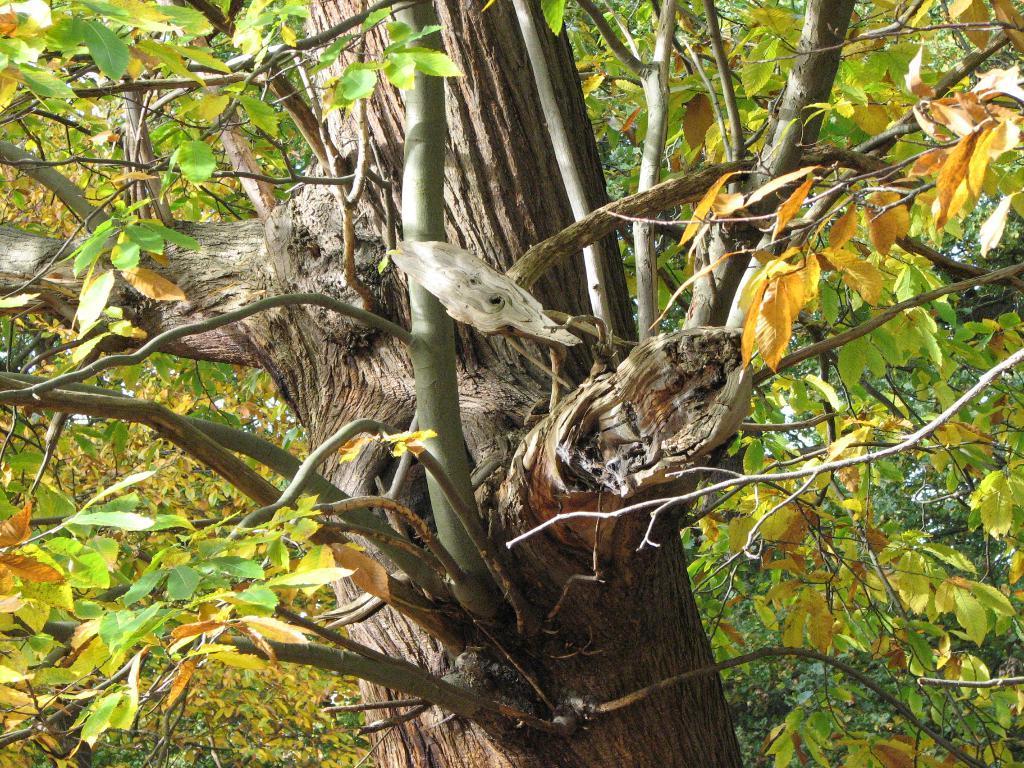How would you summarize this image in a sentence or two? In this image I see a tree and I see branches and stems on which there are leaves which are of green and orange in color. 